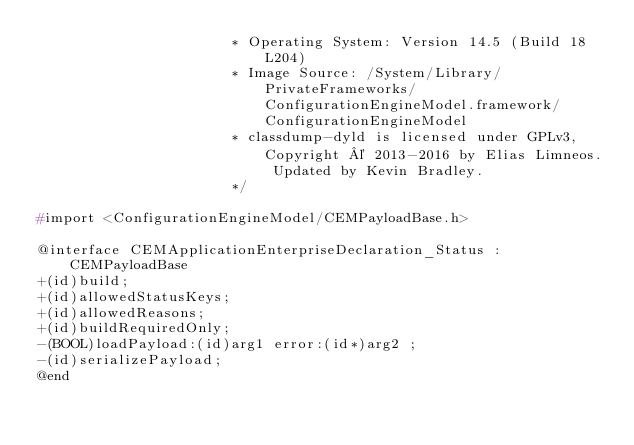<code> <loc_0><loc_0><loc_500><loc_500><_C_>                       * Operating System: Version 14.5 (Build 18L204)
                       * Image Source: /System/Library/PrivateFrameworks/ConfigurationEngineModel.framework/ConfigurationEngineModel
                       * classdump-dyld is licensed under GPLv3, Copyright © 2013-2016 by Elias Limneos. Updated by Kevin Bradley.
                       */

#import <ConfigurationEngineModel/CEMPayloadBase.h>

@interface CEMApplicationEnterpriseDeclaration_Status : CEMPayloadBase
+(id)build;
+(id)allowedStatusKeys;
+(id)allowedReasons;
+(id)buildRequiredOnly;
-(BOOL)loadPayload:(id)arg1 error:(id*)arg2 ;
-(id)serializePayload;
@end

</code> 